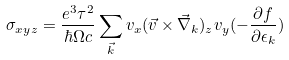<formula> <loc_0><loc_0><loc_500><loc_500>\sigma _ { x y z } = \frac { e ^ { 3 } \tau ^ { 2 } } { \hbar { \Omega } c } \sum _ { \vec { k } } v _ { x } ( \vec { v } \times \vec { \nabla } _ { k } ) _ { z } v _ { y } ( - \frac { \partial f } { \partial \epsilon _ { k } } )</formula> 